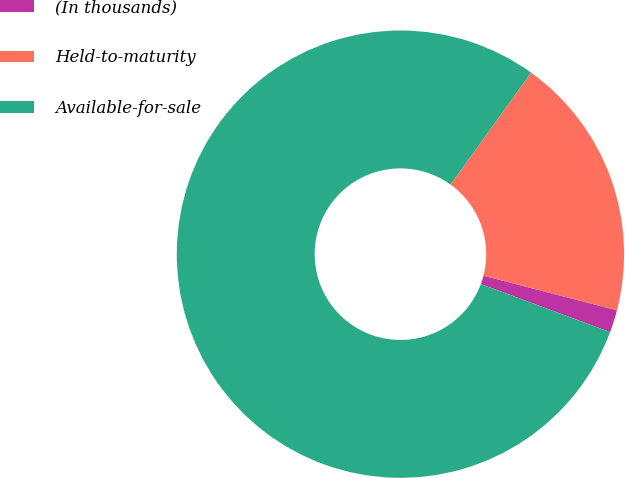Convert chart to OTSL. <chart><loc_0><loc_0><loc_500><loc_500><pie_chart><fcel>(In thousands)<fcel>Held-to-maturity<fcel>Available-for-sale<nl><fcel>1.63%<fcel>19.11%<fcel>79.27%<nl></chart> 